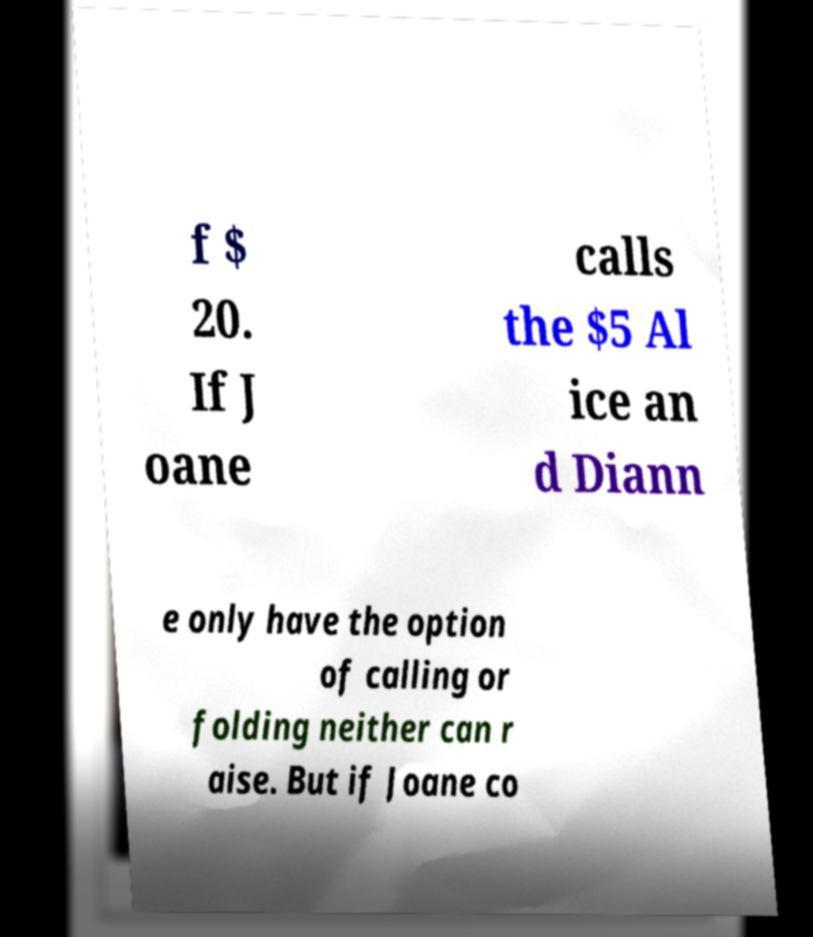Could you assist in decoding the text presented in this image and type it out clearly? f $ 20. If J oane calls the $5 Al ice an d Diann e only have the option of calling or folding neither can r aise. But if Joane co 